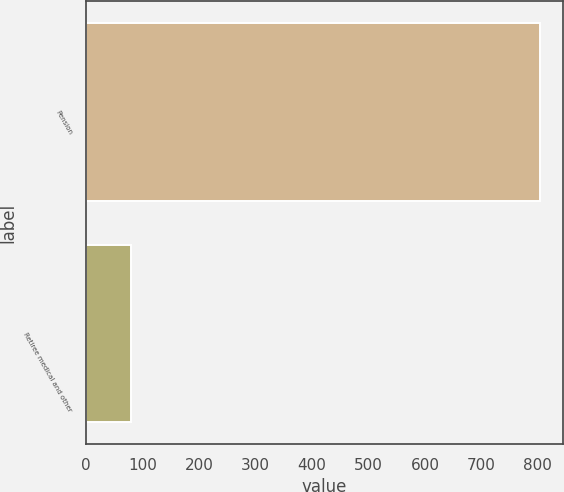<chart> <loc_0><loc_0><loc_500><loc_500><bar_chart><fcel>Pension<fcel>Retiree medical and other<nl><fcel>804<fcel>79<nl></chart> 